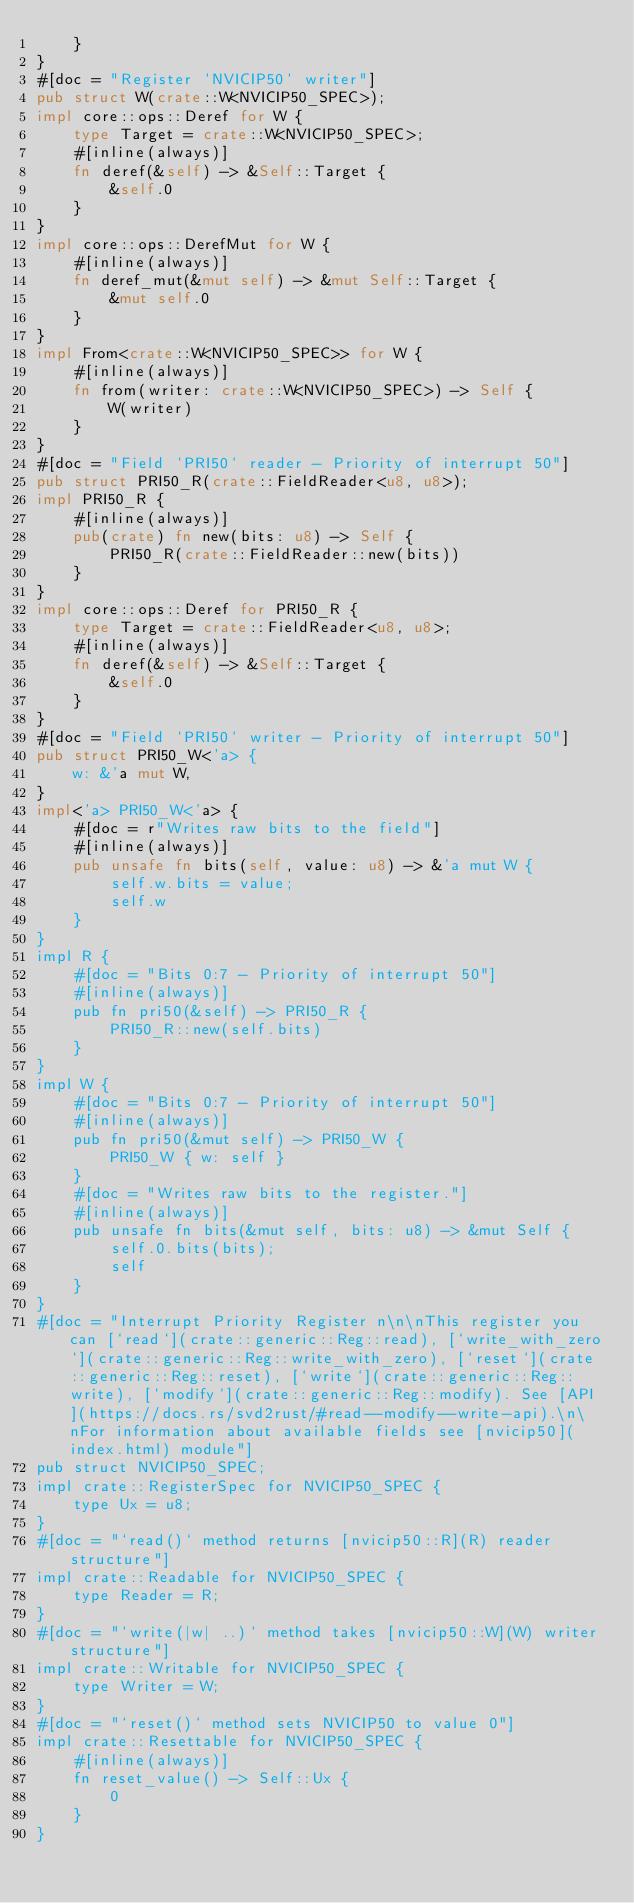Convert code to text. <code><loc_0><loc_0><loc_500><loc_500><_Rust_>    }
}
#[doc = "Register `NVICIP50` writer"]
pub struct W(crate::W<NVICIP50_SPEC>);
impl core::ops::Deref for W {
    type Target = crate::W<NVICIP50_SPEC>;
    #[inline(always)]
    fn deref(&self) -> &Self::Target {
        &self.0
    }
}
impl core::ops::DerefMut for W {
    #[inline(always)]
    fn deref_mut(&mut self) -> &mut Self::Target {
        &mut self.0
    }
}
impl From<crate::W<NVICIP50_SPEC>> for W {
    #[inline(always)]
    fn from(writer: crate::W<NVICIP50_SPEC>) -> Self {
        W(writer)
    }
}
#[doc = "Field `PRI50` reader - Priority of interrupt 50"]
pub struct PRI50_R(crate::FieldReader<u8, u8>);
impl PRI50_R {
    #[inline(always)]
    pub(crate) fn new(bits: u8) -> Self {
        PRI50_R(crate::FieldReader::new(bits))
    }
}
impl core::ops::Deref for PRI50_R {
    type Target = crate::FieldReader<u8, u8>;
    #[inline(always)]
    fn deref(&self) -> &Self::Target {
        &self.0
    }
}
#[doc = "Field `PRI50` writer - Priority of interrupt 50"]
pub struct PRI50_W<'a> {
    w: &'a mut W,
}
impl<'a> PRI50_W<'a> {
    #[doc = r"Writes raw bits to the field"]
    #[inline(always)]
    pub unsafe fn bits(self, value: u8) -> &'a mut W {
        self.w.bits = value;
        self.w
    }
}
impl R {
    #[doc = "Bits 0:7 - Priority of interrupt 50"]
    #[inline(always)]
    pub fn pri50(&self) -> PRI50_R {
        PRI50_R::new(self.bits)
    }
}
impl W {
    #[doc = "Bits 0:7 - Priority of interrupt 50"]
    #[inline(always)]
    pub fn pri50(&mut self) -> PRI50_W {
        PRI50_W { w: self }
    }
    #[doc = "Writes raw bits to the register."]
    #[inline(always)]
    pub unsafe fn bits(&mut self, bits: u8) -> &mut Self {
        self.0.bits(bits);
        self
    }
}
#[doc = "Interrupt Priority Register n\n\nThis register you can [`read`](crate::generic::Reg::read), [`write_with_zero`](crate::generic::Reg::write_with_zero), [`reset`](crate::generic::Reg::reset), [`write`](crate::generic::Reg::write), [`modify`](crate::generic::Reg::modify). See [API](https://docs.rs/svd2rust/#read--modify--write-api).\n\nFor information about available fields see [nvicip50](index.html) module"]
pub struct NVICIP50_SPEC;
impl crate::RegisterSpec for NVICIP50_SPEC {
    type Ux = u8;
}
#[doc = "`read()` method returns [nvicip50::R](R) reader structure"]
impl crate::Readable for NVICIP50_SPEC {
    type Reader = R;
}
#[doc = "`write(|w| ..)` method takes [nvicip50::W](W) writer structure"]
impl crate::Writable for NVICIP50_SPEC {
    type Writer = W;
}
#[doc = "`reset()` method sets NVICIP50 to value 0"]
impl crate::Resettable for NVICIP50_SPEC {
    #[inline(always)]
    fn reset_value() -> Self::Ux {
        0
    }
}
</code> 